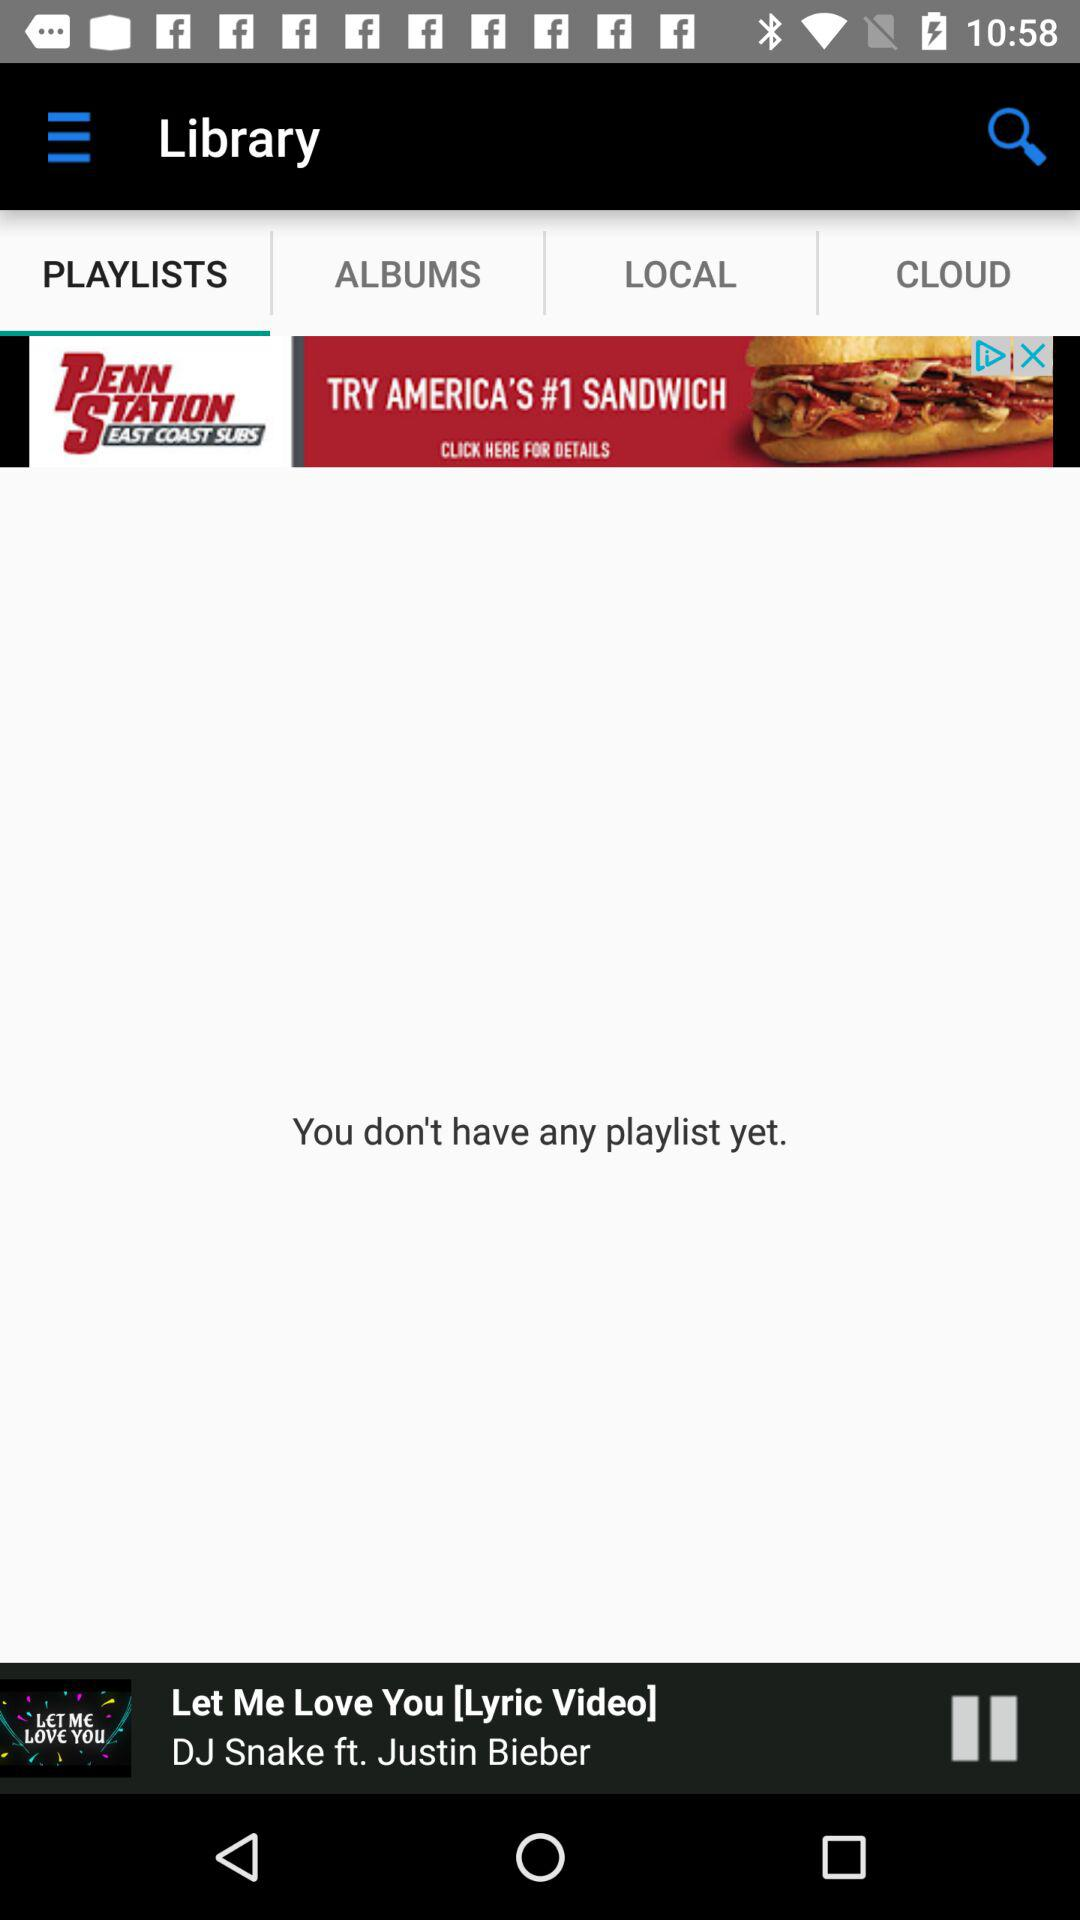What song is currently playing? The currently playing song is "Let Me Love You". 